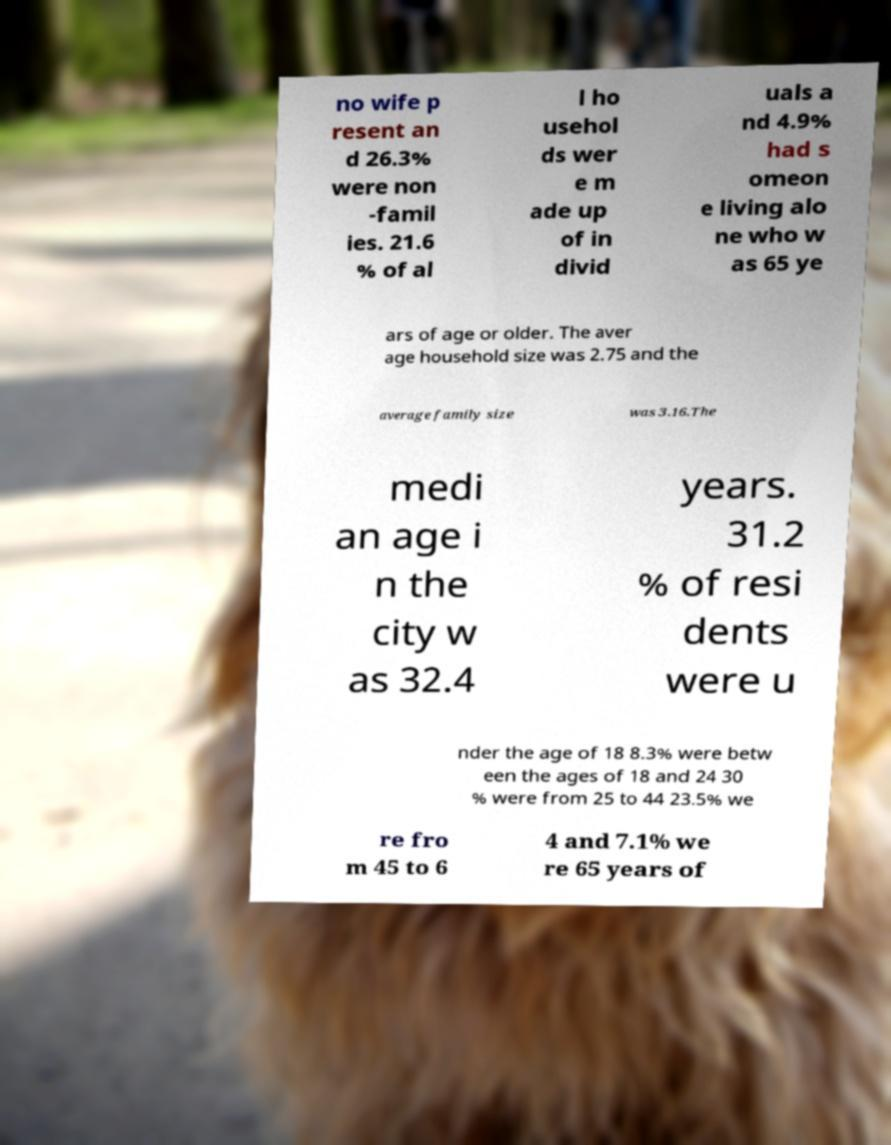Can you accurately transcribe the text from the provided image for me? no wife p resent an d 26.3% were non -famil ies. 21.6 % of al l ho usehol ds wer e m ade up of in divid uals a nd 4.9% had s omeon e living alo ne who w as 65 ye ars of age or older. The aver age household size was 2.75 and the average family size was 3.16.The medi an age i n the city w as 32.4 years. 31.2 % of resi dents were u nder the age of 18 8.3% were betw een the ages of 18 and 24 30 % were from 25 to 44 23.5% we re fro m 45 to 6 4 and 7.1% we re 65 years of 